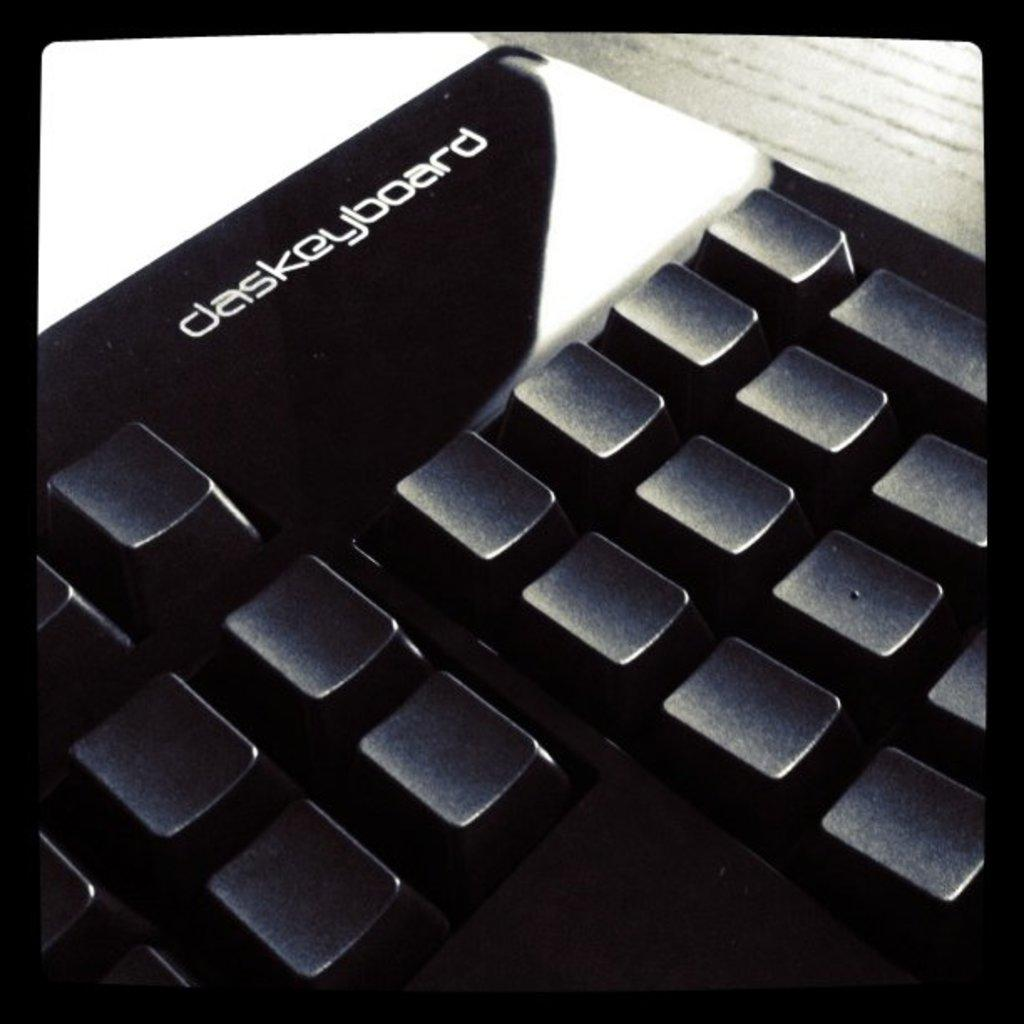What is the main object in the image? There is a keyboard in the image. Where is the keyboard located? The keyboard is placed on a table. How many passengers are on the island in the image? There is no island or passengers present in the image; it only features a keyboard placed on a table. What type of cord is connected to the keyboard in the image? There is no cord connected to the keyboard in the image. 